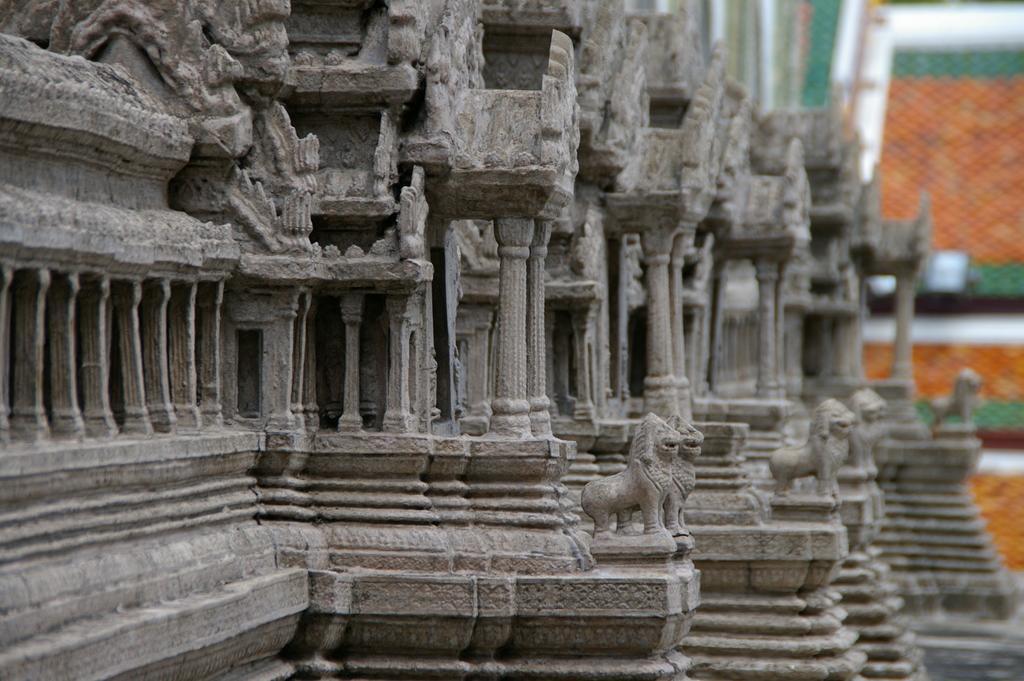Please provide a concise description of this image. In this image I can see a building in gray color and I can see green and orange color background. 